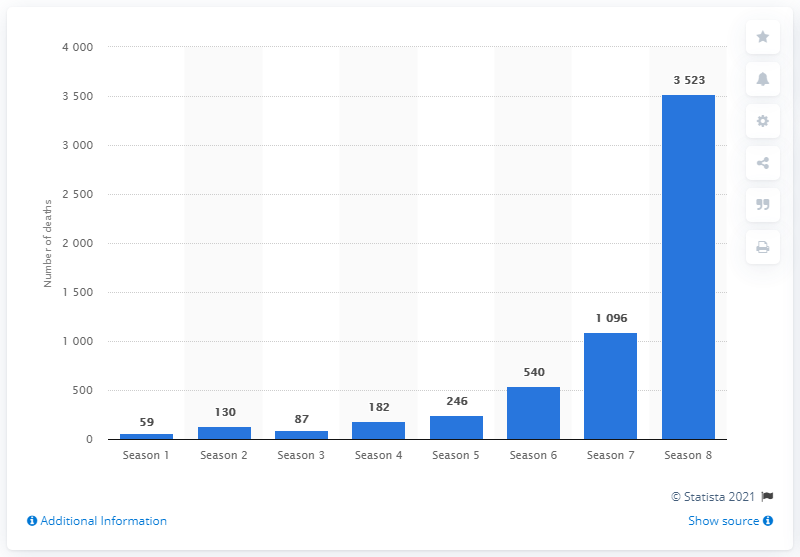Identify some key points in this picture. In the first season of Game of Thrones, 59 people died. 